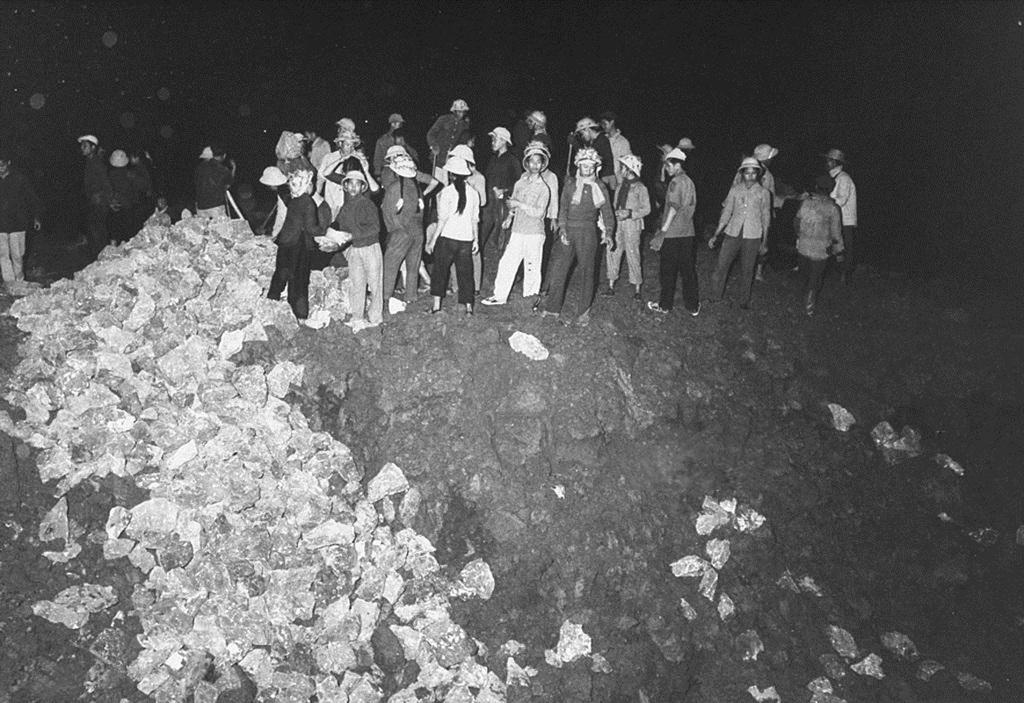What is the color scheme of the image? The image is black and white. What can be seen on the surface in the image? There are people standing on the surface in the image. What is located on the left side of the image? There are covers on the left side of the image. What are the people doing with the covers? The people are collecting the covers. What type of cactus can be seen in the image? There is no cactus present in the image. What reason do the people have for collecting the covers in the image? The provided facts do not mention a reason for the people collecting the covers; we can only observe their actions in the image. 